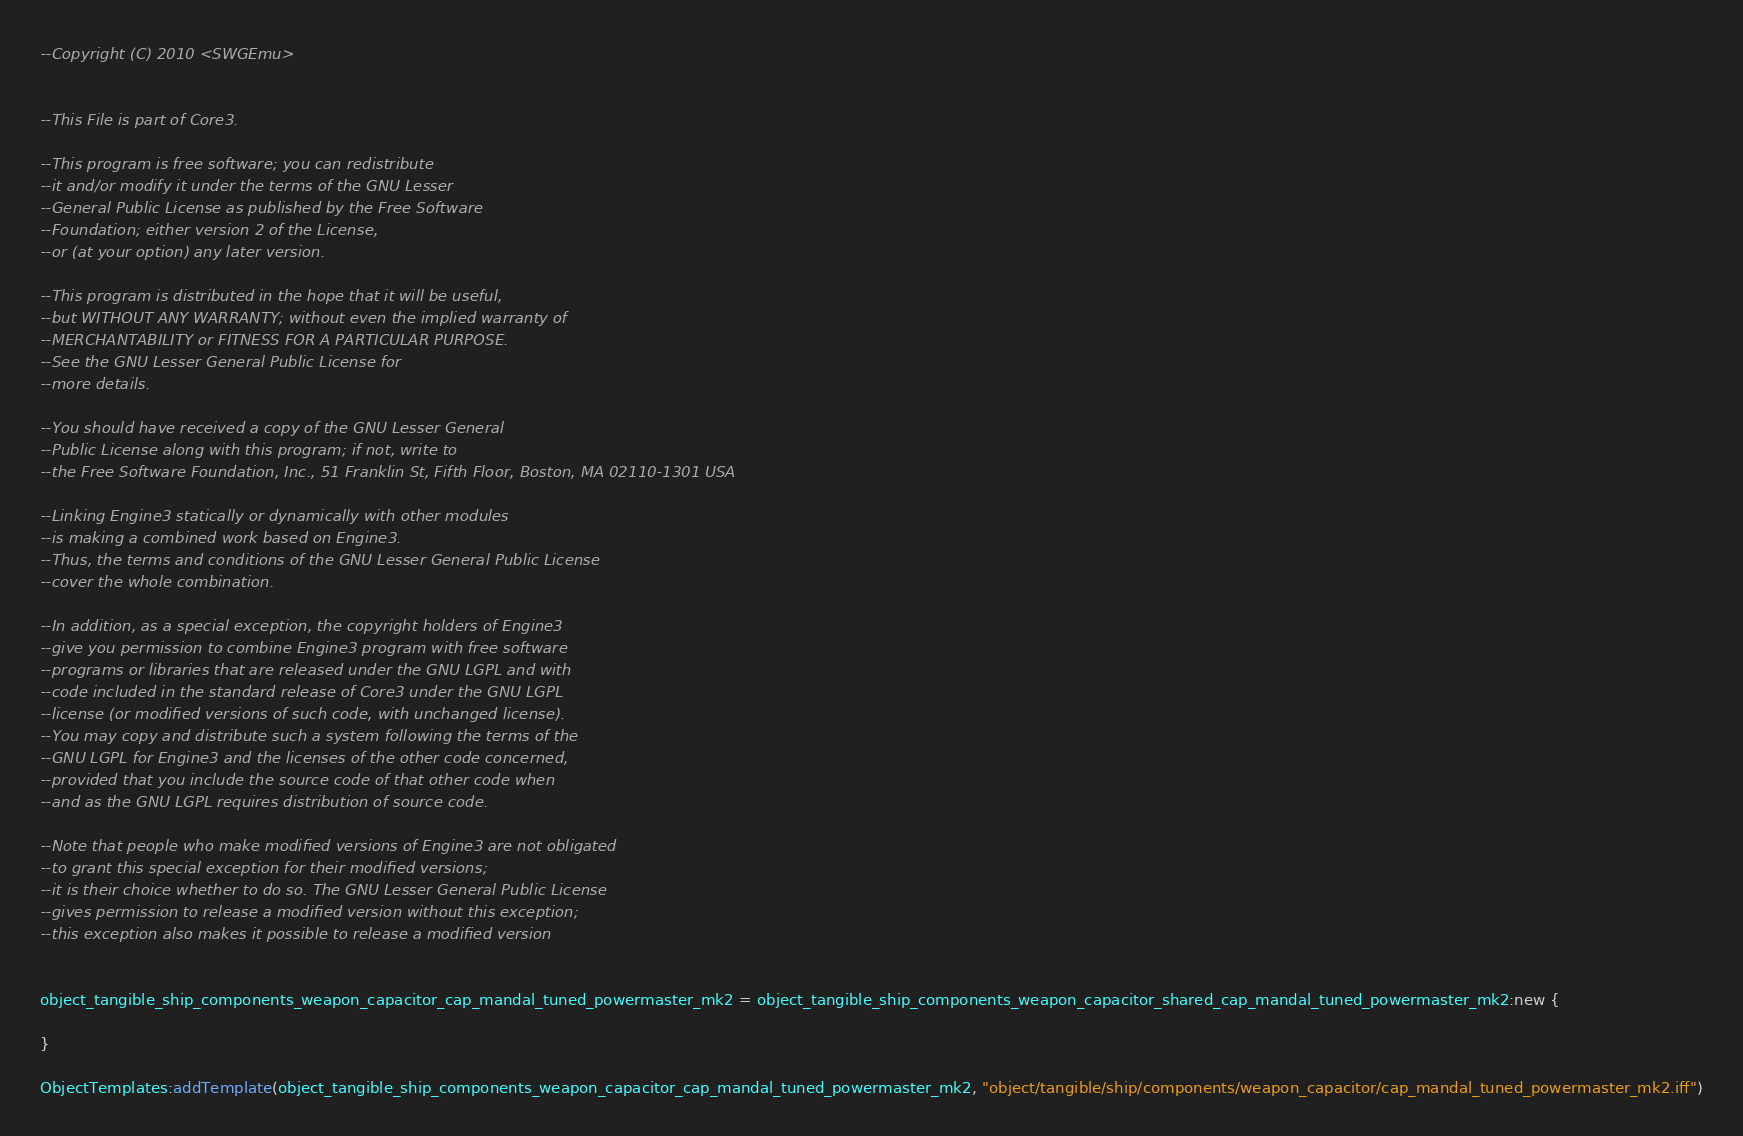Convert code to text. <code><loc_0><loc_0><loc_500><loc_500><_Lua_>--Copyright (C) 2010 <SWGEmu>


--This File is part of Core3.

--This program is free software; you can redistribute 
--it and/or modify it under the terms of the GNU Lesser 
--General Public License as published by the Free Software
--Foundation; either version 2 of the License, 
--or (at your option) any later version.

--This program is distributed in the hope that it will be useful, 
--but WITHOUT ANY WARRANTY; without even the implied warranty of 
--MERCHANTABILITY or FITNESS FOR A PARTICULAR PURPOSE. 
--See the GNU Lesser General Public License for
--more details.

--You should have received a copy of the GNU Lesser General 
--Public License along with this program; if not, write to
--the Free Software Foundation, Inc., 51 Franklin St, Fifth Floor, Boston, MA 02110-1301 USA

--Linking Engine3 statically or dynamically with other modules 
--is making a combined work based on Engine3. 
--Thus, the terms and conditions of the GNU Lesser General Public License 
--cover the whole combination.

--In addition, as a special exception, the copyright holders of Engine3 
--give you permission to combine Engine3 program with free software 
--programs or libraries that are released under the GNU LGPL and with 
--code included in the standard release of Core3 under the GNU LGPL 
--license (or modified versions of such code, with unchanged license). 
--You may copy and distribute such a system following the terms of the 
--GNU LGPL for Engine3 and the licenses of the other code concerned, 
--provided that you include the source code of that other code when 
--and as the GNU LGPL requires distribution of source code.

--Note that people who make modified versions of Engine3 are not obligated 
--to grant this special exception for their modified versions; 
--it is their choice whether to do so. The GNU Lesser General Public License 
--gives permission to release a modified version without this exception; 
--this exception also makes it possible to release a modified version 


object_tangible_ship_components_weapon_capacitor_cap_mandal_tuned_powermaster_mk2 = object_tangible_ship_components_weapon_capacitor_shared_cap_mandal_tuned_powermaster_mk2:new {

}

ObjectTemplates:addTemplate(object_tangible_ship_components_weapon_capacitor_cap_mandal_tuned_powermaster_mk2, "object/tangible/ship/components/weapon_capacitor/cap_mandal_tuned_powermaster_mk2.iff")
</code> 